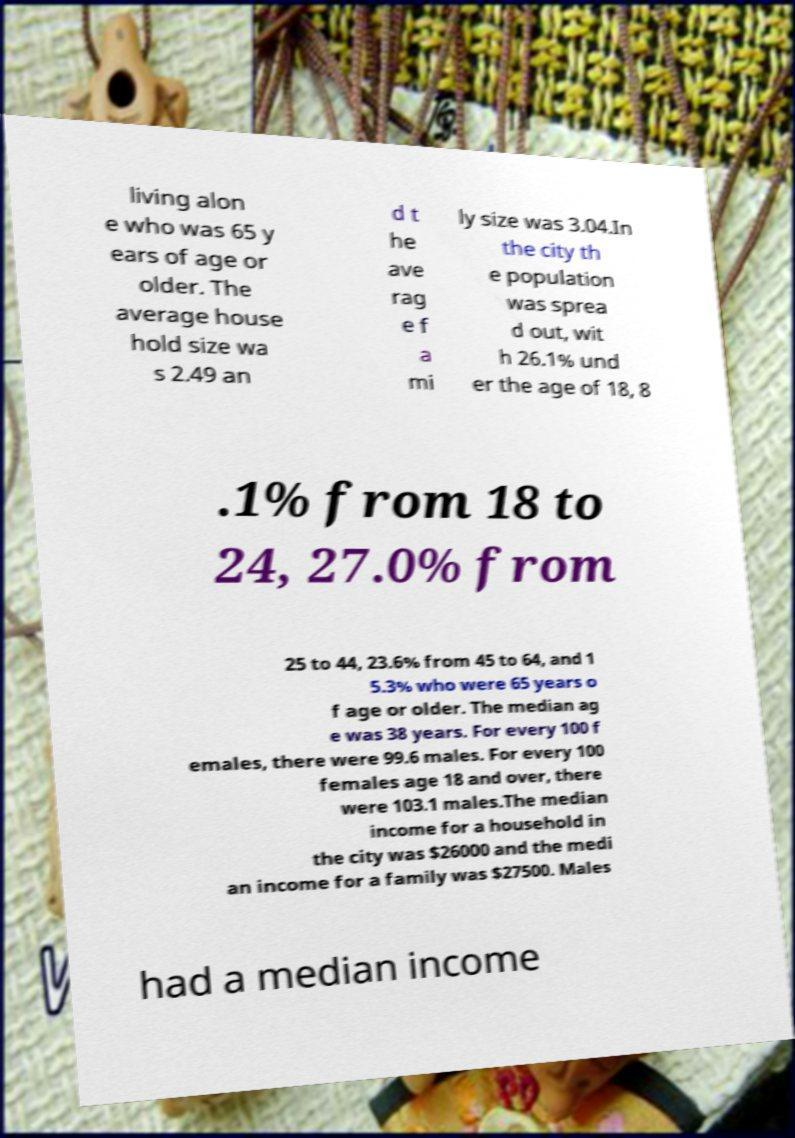Could you extract and type out the text from this image? living alon e who was 65 y ears of age or older. The average house hold size wa s 2.49 an d t he ave rag e f a mi ly size was 3.04.In the city th e population was sprea d out, wit h 26.1% und er the age of 18, 8 .1% from 18 to 24, 27.0% from 25 to 44, 23.6% from 45 to 64, and 1 5.3% who were 65 years o f age or older. The median ag e was 38 years. For every 100 f emales, there were 99.6 males. For every 100 females age 18 and over, there were 103.1 males.The median income for a household in the city was $26000 and the medi an income for a family was $27500. Males had a median income 